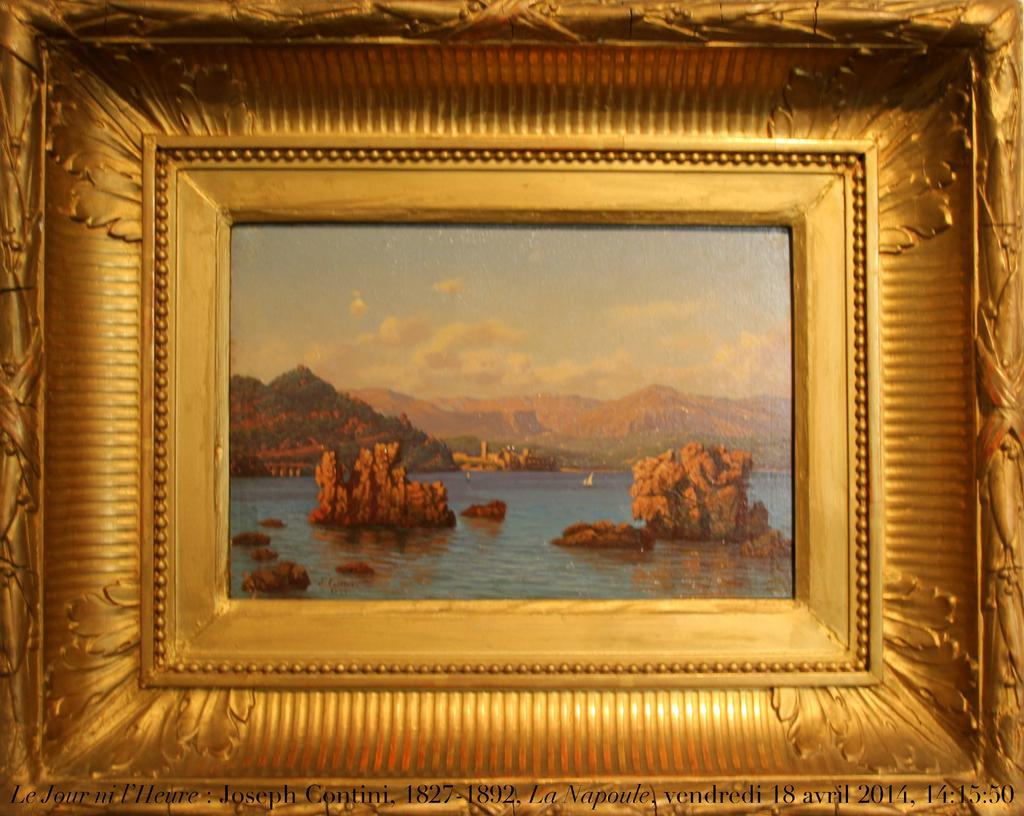What object is present in the image that contains pictures? There is a photo frame in the image. What types of scenes are depicted in the photo frame? The photo frame contains a picture of a river, mountains, and the sky. How many cherries are hanging from the mountain in the image? There are no cherries present in the image, as it only contains pictures of a river, mountains, and the sky. 